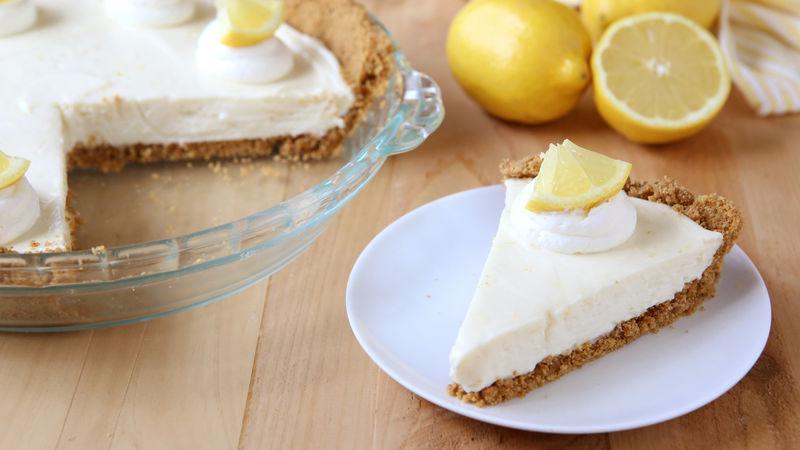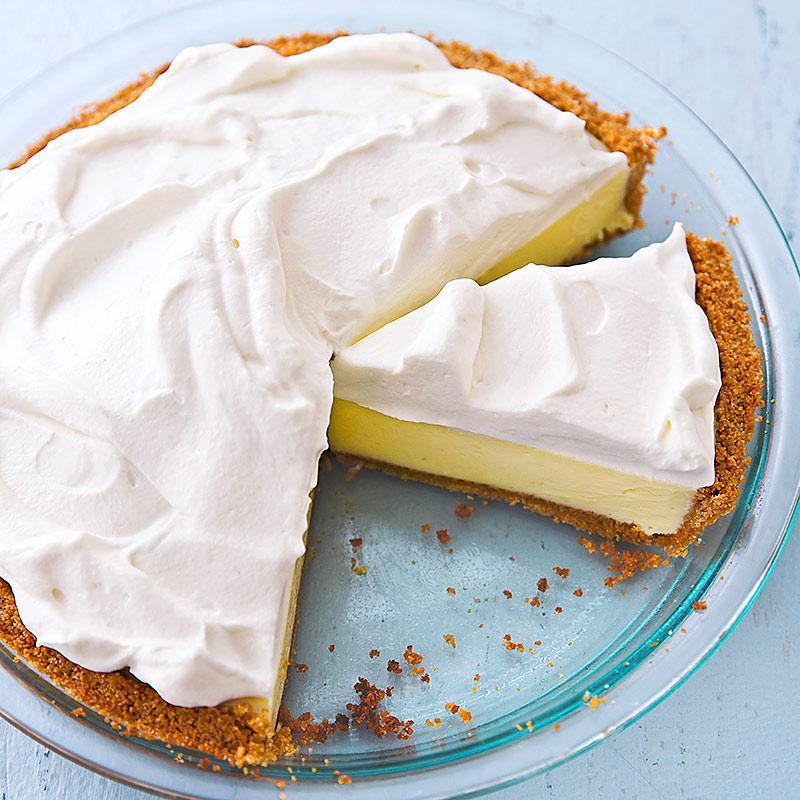The first image is the image on the left, the second image is the image on the right. Assess this claim about the two images: "The left image shows one pie slice on a white plate, and the right image shows a pie with a slice missing and includes an individual slice.". Correct or not? Answer yes or no. Yes. The first image is the image on the left, the second image is the image on the right. Given the left and right images, does the statement "There is one whole pie." hold true? Answer yes or no. No. 